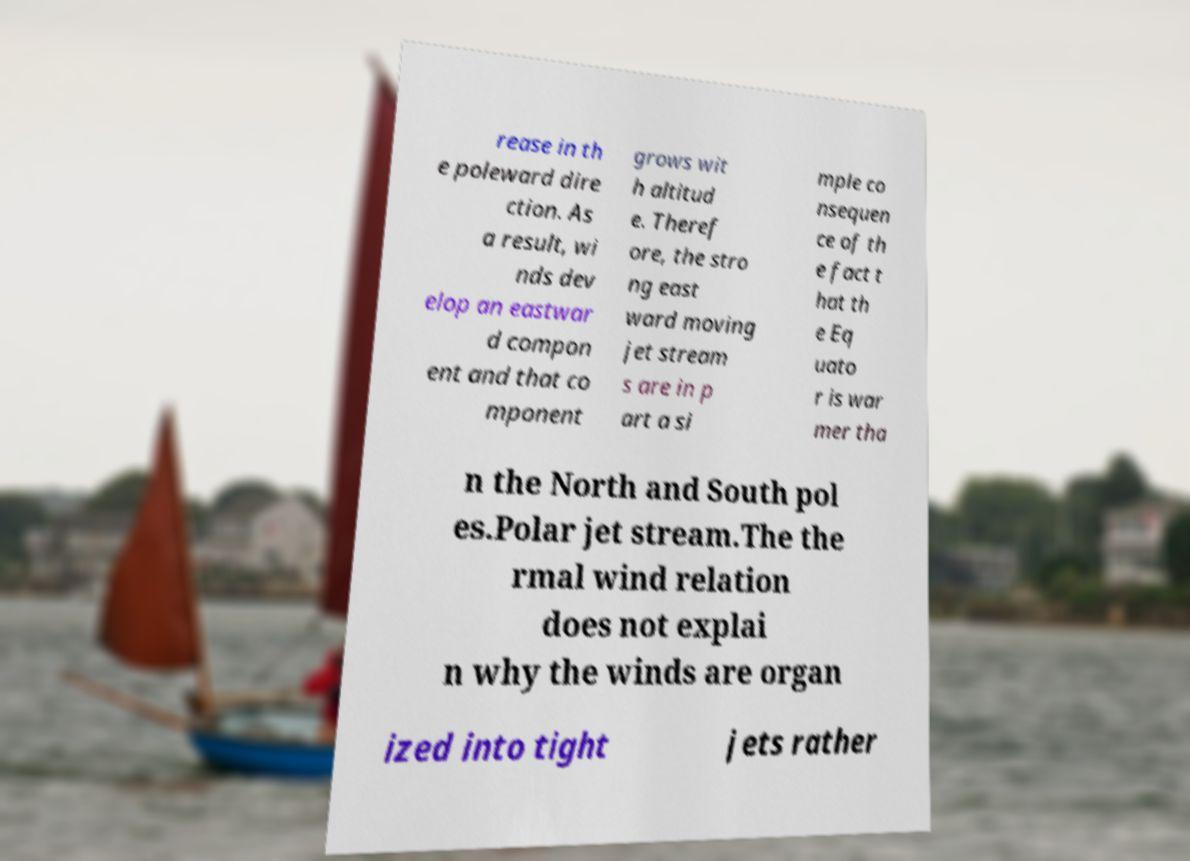What messages or text are displayed in this image? I need them in a readable, typed format. rease in th e poleward dire ction. As a result, wi nds dev elop an eastwar d compon ent and that co mponent grows wit h altitud e. Theref ore, the stro ng east ward moving jet stream s are in p art a si mple co nsequen ce of th e fact t hat th e Eq uato r is war mer tha n the North and South pol es.Polar jet stream.The the rmal wind relation does not explai n why the winds are organ ized into tight jets rather 